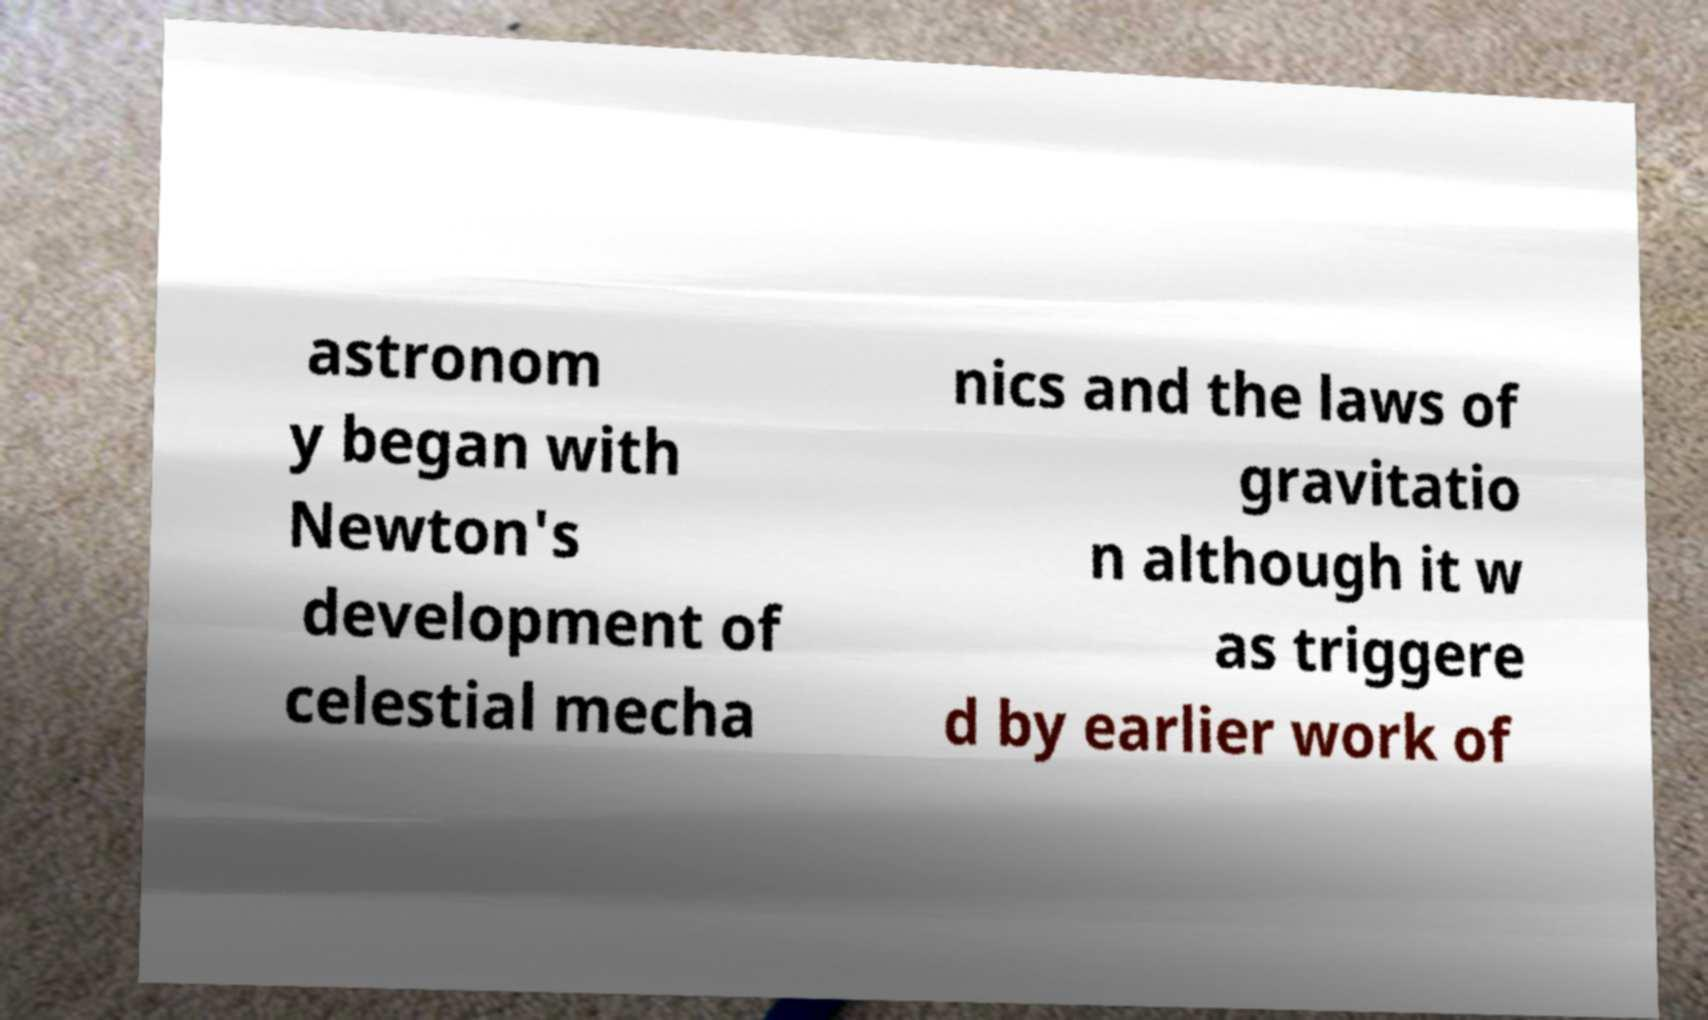What messages or text are displayed in this image? I need them in a readable, typed format. astronom y began with Newton's development of celestial mecha nics and the laws of gravitatio n although it w as triggere d by earlier work of 